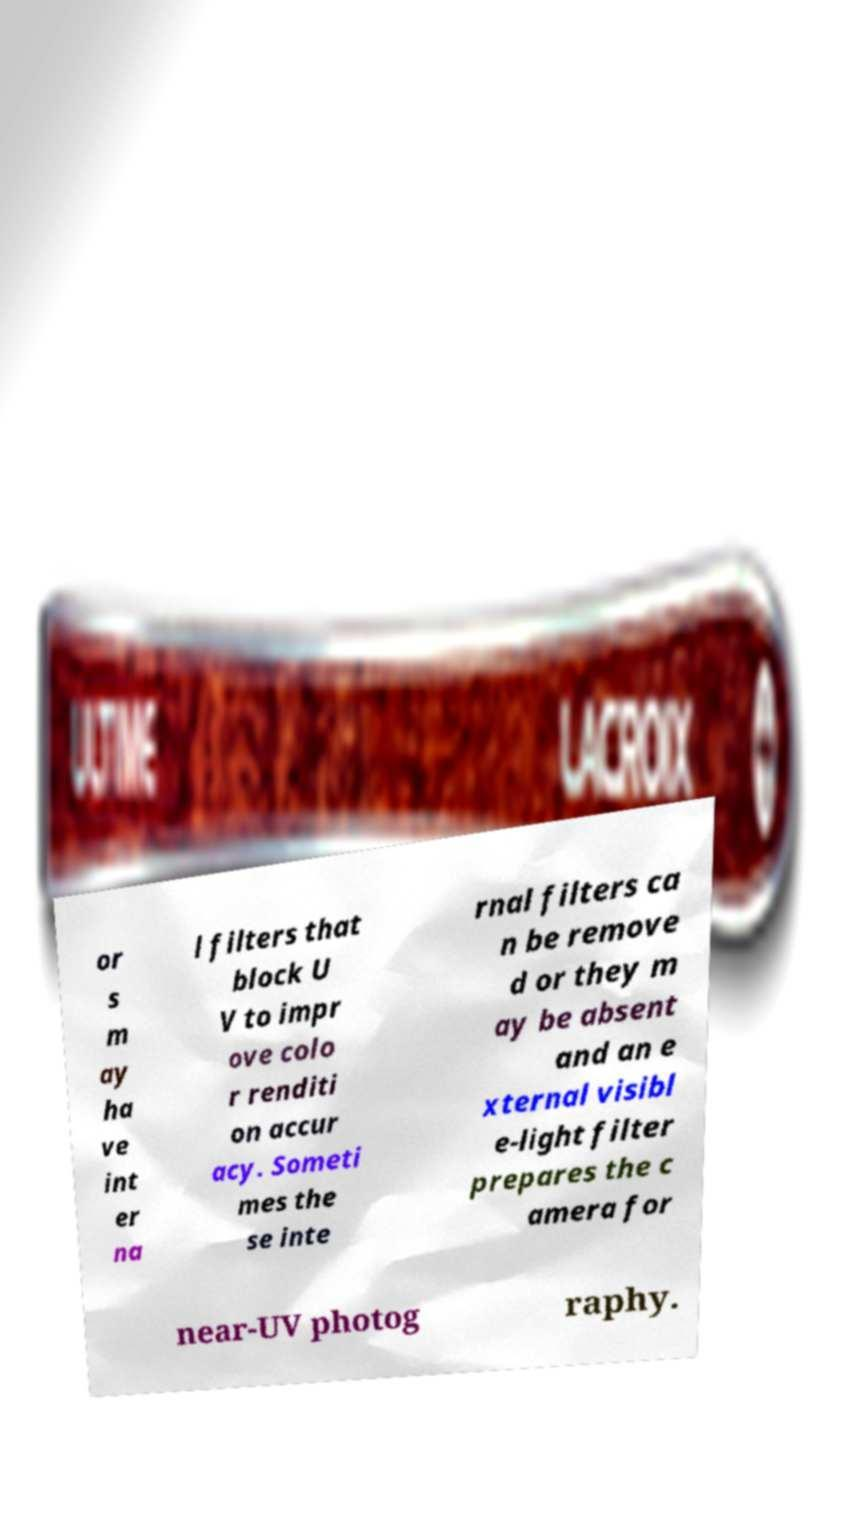Could you assist in decoding the text presented in this image and type it out clearly? or s m ay ha ve int er na l filters that block U V to impr ove colo r renditi on accur acy. Someti mes the se inte rnal filters ca n be remove d or they m ay be absent and an e xternal visibl e-light filter prepares the c amera for near-UV photog raphy. 